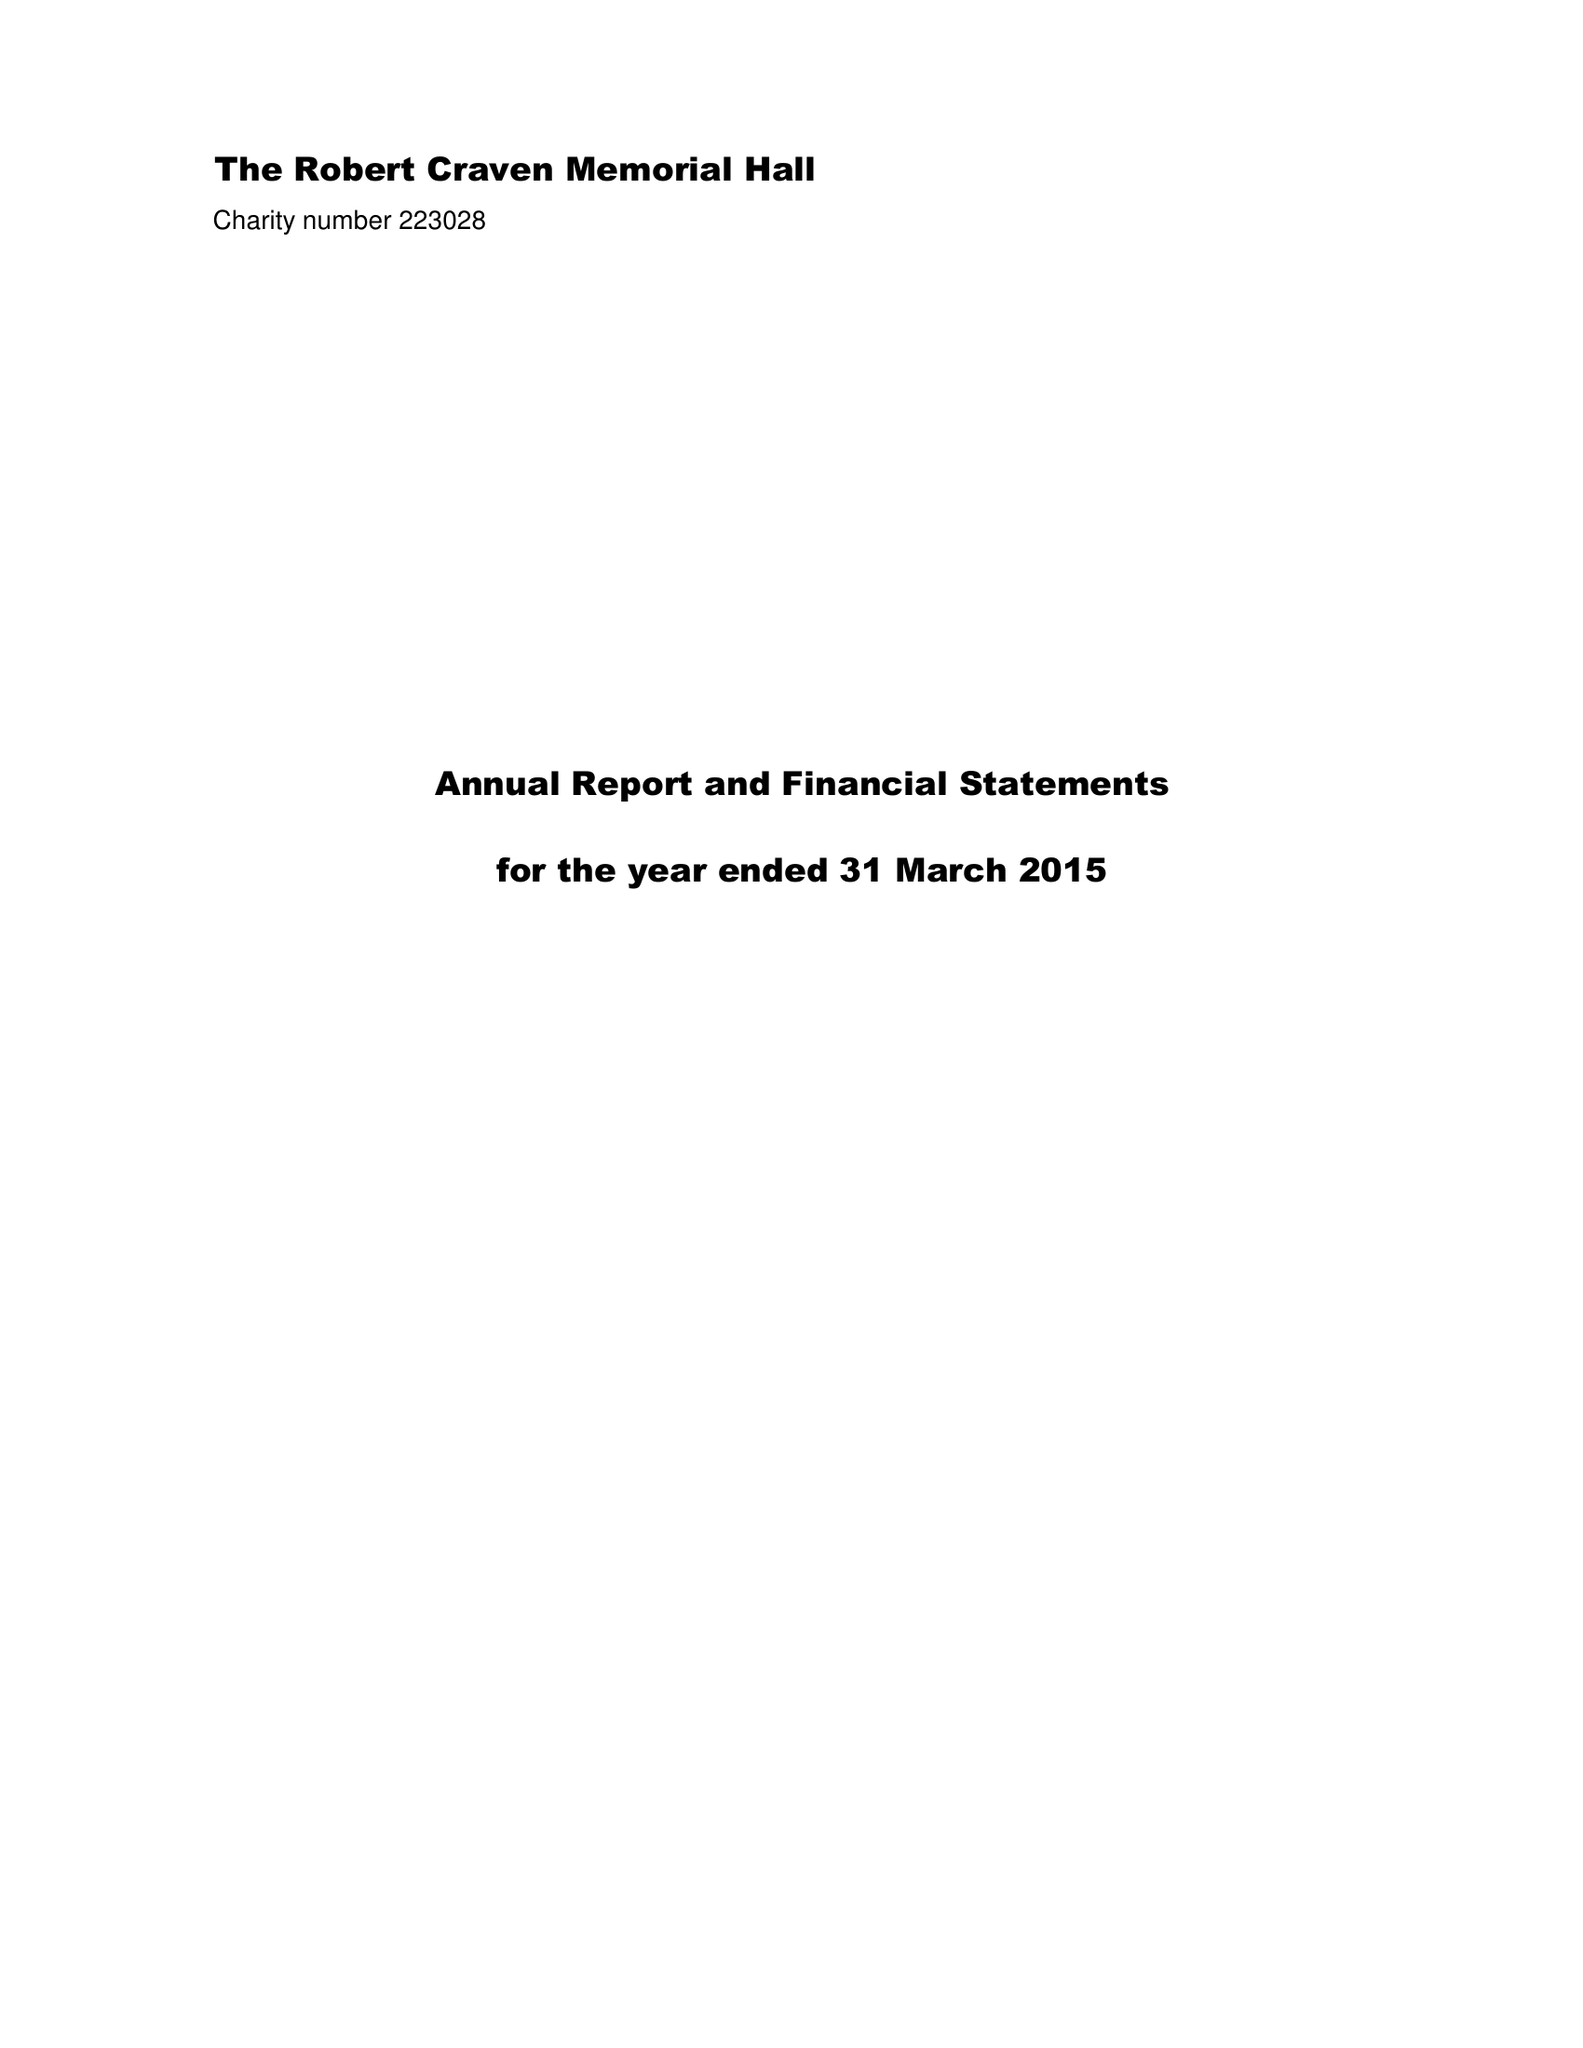What is the value for the charity_number?
Answer the question using a single word or phrase. 223028 